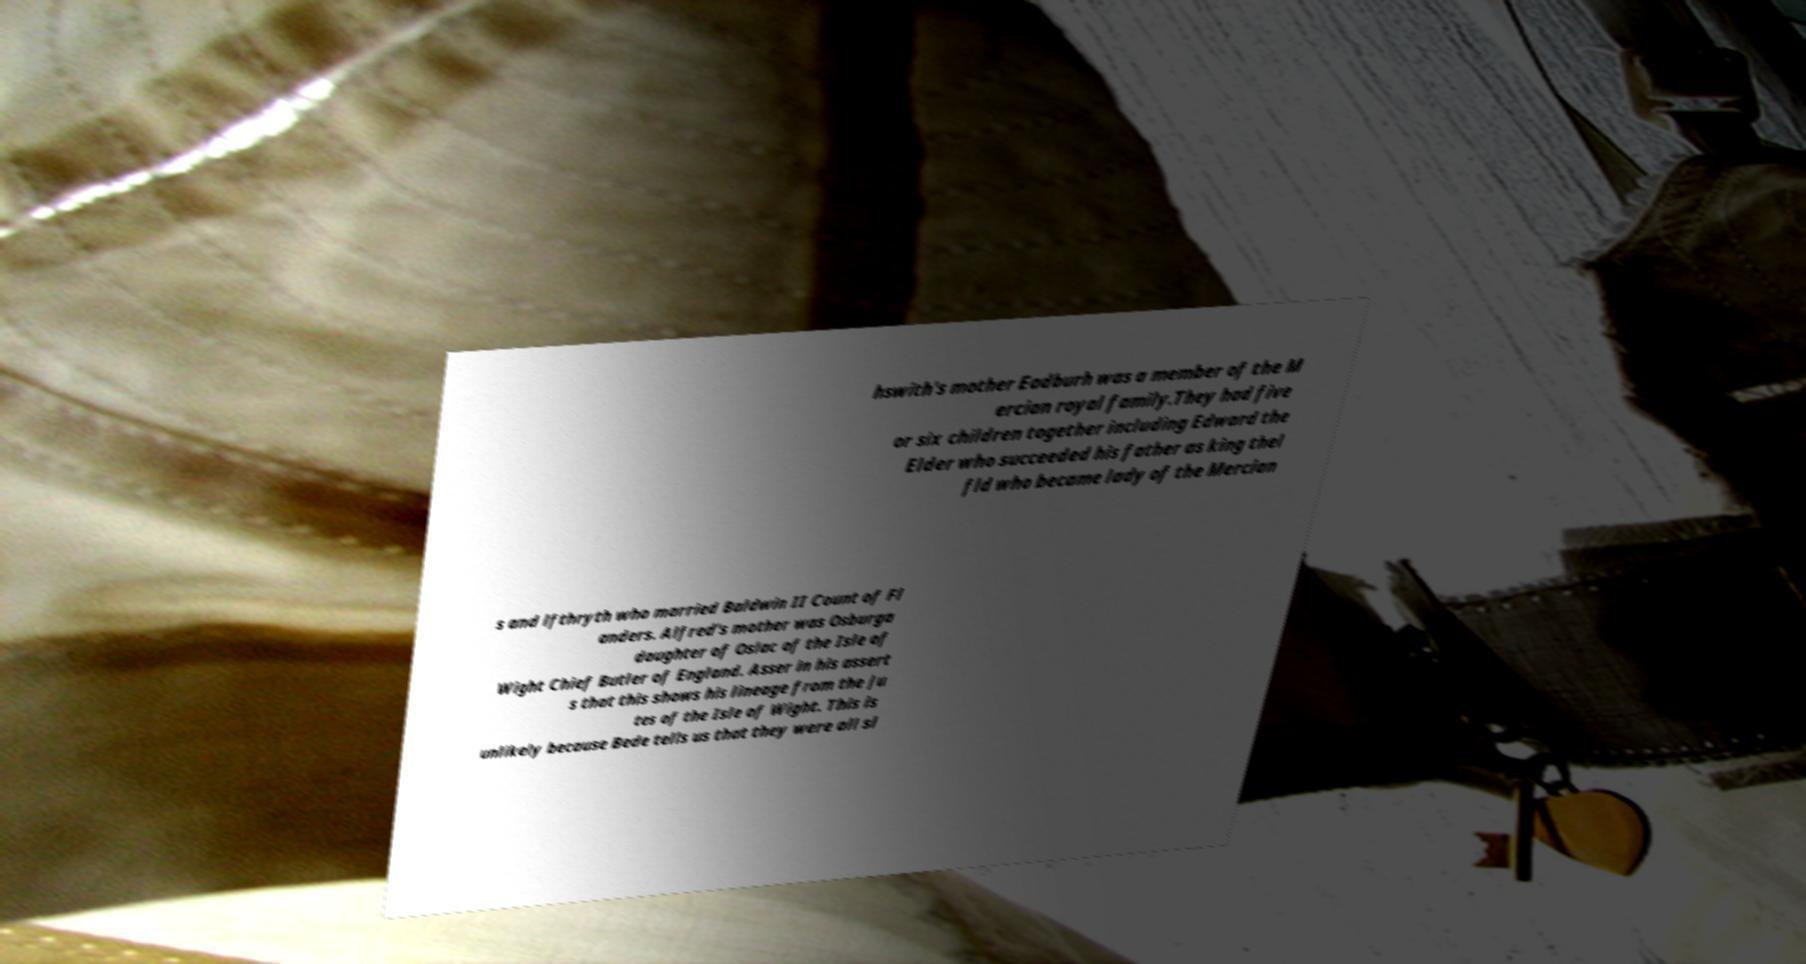Could you extract and type out the text from this image? hswith's mother Eadburh was a member of the M ercian royal family.They had five or six children together including Edward the Elder who succeeded his father as king thel fld who became lady of the Mercian s and lfthryth who married Baldwin II Count of Fl anders. Alfred's mother was Osburga daughter of Oslac of the Isle of Wight Chief Butler of England. Asser in his assert s that this shows his lineage from the Ju tes of the Isle of Wight. This is unlikely because Bede tells us that they were all sl 